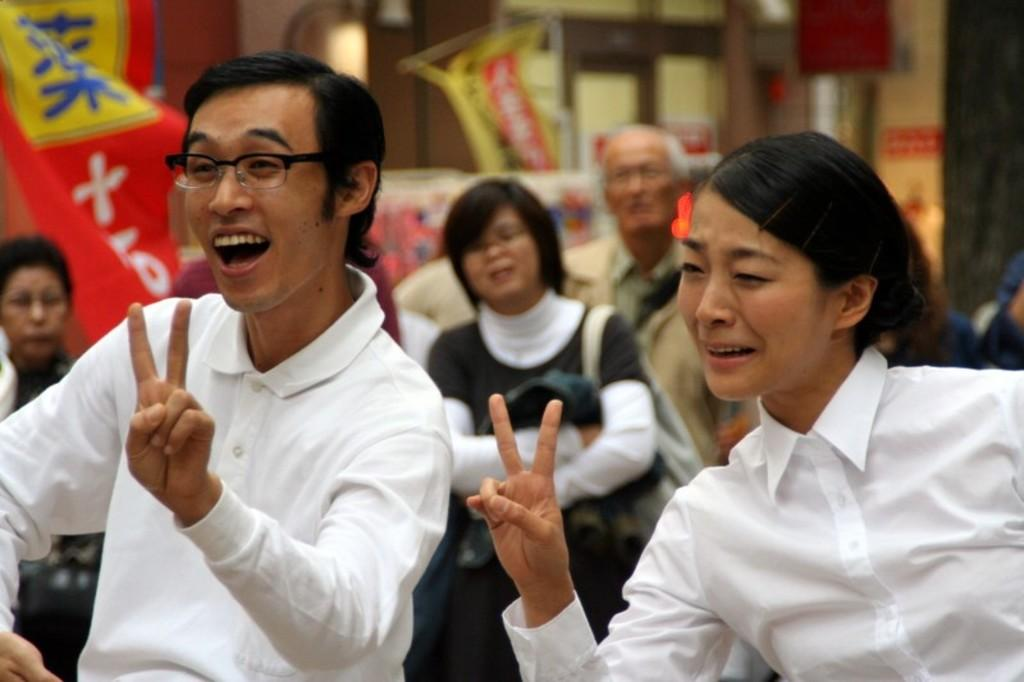Who are the people in the image? There is a man and a lady in the image. What are the expressions on their faces? Both the man and the lady are smiling in the image. What are they doing with their fingers? The man and the lady are showing their fingers in the image. What can be seen in the background of the image? There are people and banners visible in the background. What type of jam is being spread on the plant in the image? There is no jam or plant present in the image; it features a man and a lady showing their fingers. What color is the house in the image? There is no house present in the image. 